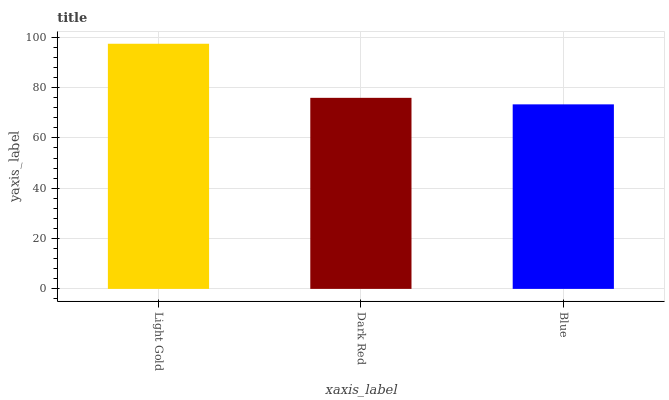Is Blue the minimum?
Answer yes or no. Yes. Is Light Gold the maximum?
Answer yes or no. Yes. Is Dark Red the minimum?
Answer yes or no. No. Is Dark Red the maximum?
Answer yes or no. No. Is Light Gold greater than Dark Red?
Answer yes or no. Yes. Is Dark Red less than Light Gold?
Answer yes or no. Yes. Is Dark Red greater than Light Gold?
Answer yes or no. No. Is Light Gold less than Dark Red?
Answer yes or no. No. Is Dark Red the high median?
Answer yes or no. Yes. Is Dark Red the low median?
Answer yes or no. Yes. Is Blue the high median?
Answer yes or no. No. Is Blue the low median?
Answer yes or no. No. 